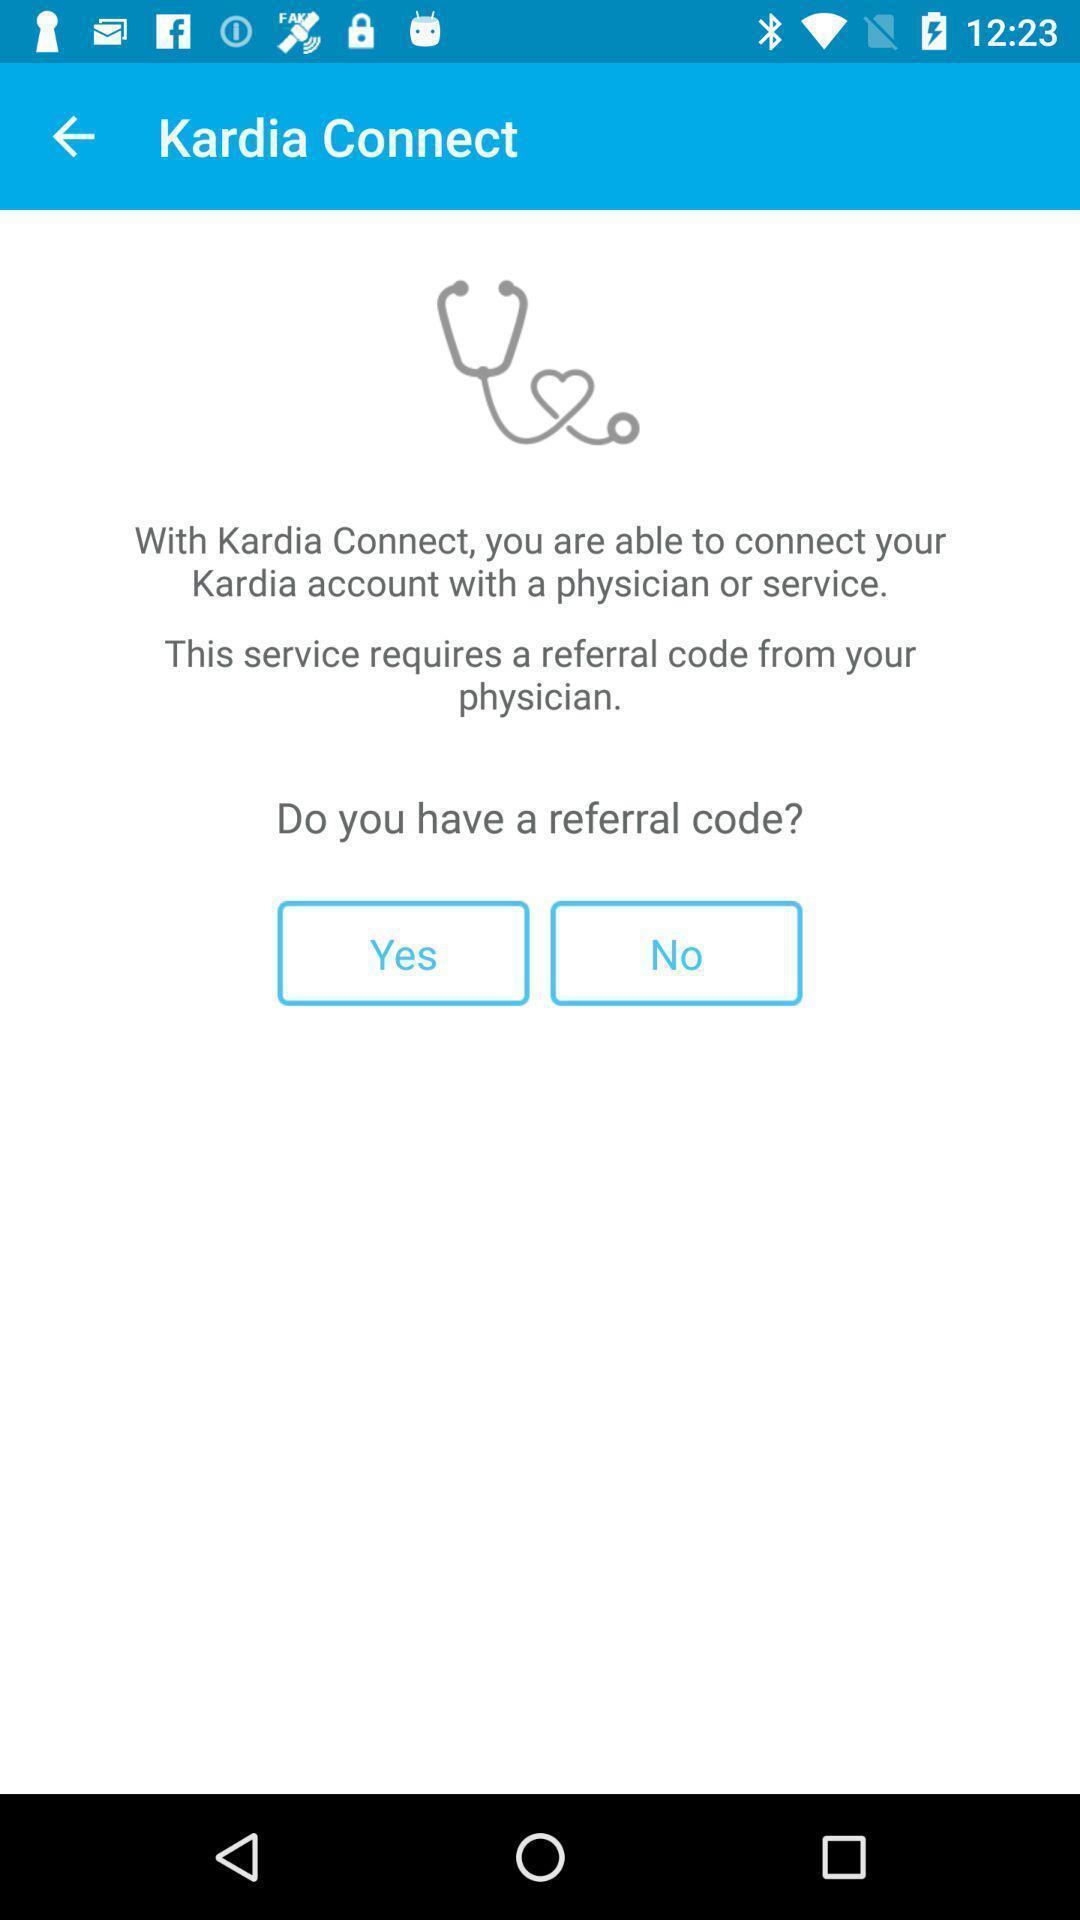Summarize the information in this screenshot. Page shows few options in a health app. 